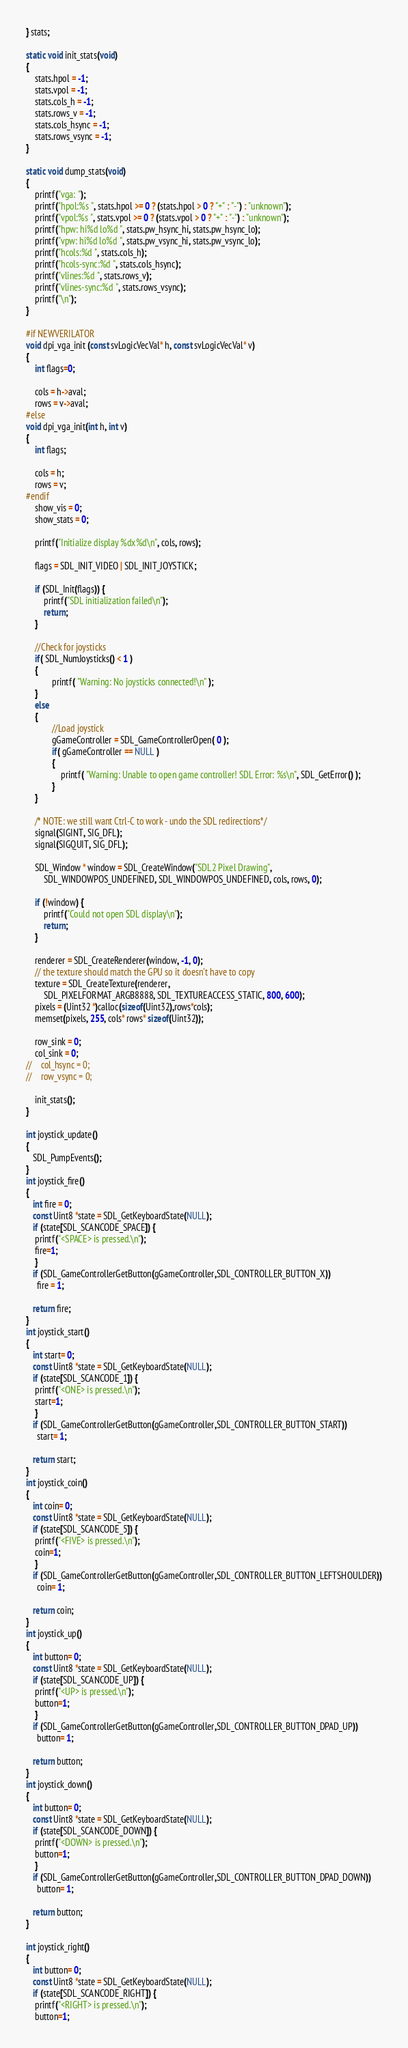<code> <loc_0><loc_0><loc_500><loc_500><_C++_>} stats;

static void init_stats(void)
{
    stats.hpol = -1;
    stats.vpol = -1;
    stats.cols_h = -1;
    stats.rows_v = -1;
    stats.cols_hsync = -1;
    stats.rows_vsync = -1;
}

static void dump_stats(void)
{
    printf("vga: ");
    printf("hpol:%s ", stats.hpol >= 0 ? (stats.hpol > 0 ? "+" : "-") : "unknown");
    printf("vpol:%s ", stats.vpol >= 0 ? (stats.vpol > 0 ? "+" : "-") : "unknown");
    printf("hpw: hi%d lo%d ", stats.pw_hsync_hi, stats.pw_hsync_lo);
    printf("vpw: hi%d lo%d ", stats.pw_vsync_hi, stats.pw_vsync_lo);
    printf("hcols:%d ", stats.cols_h);
    printf("hcols-sync:%d ", stats.cols_hsync);
    printf("vlines:%d ", stats.rows_v);
    printf("vlines-sync:%d ", stats.rows_vsync);
    printf("\n");
}

#if NEWVERILATOR
void dpi_vga_init (const svLogicVecVal* h, const svLogicVecVal* v)
{
    int flags=0;

    cols = h->aval;
    rows = v->aval;
#else
void dpi_vga_init(int h, int v)
{
    int flags;

    cols = h;
    rows = v;
#endif
    show_vis = 0;
    show_stats = 0;

    printf("Initialize display %dx%d\n", cols, rows);

    flags = SDL_INIT_VIDEO | SDL_INIT_JOYSTICK;

    if (SDL_Init(flags)) {
        printf("SDL initialization failed\n");
        return;
    }

    //Check for joysticks
    if( SDL_NumJoysticks() < 1 )
    {
            printf( "Warning: No joysticks connected!\n" );
    }
    else
    {
            //Load joystick
            gGameController = SDL_GameControllerOpen( 0 );
            if( gGameController == NULL )
            {
                printf( "Warning: Unable to open game controller! SDL Error: %s\n", SDL_GetError() );
            }
    }

    /* NOTE: we still want Ctrl-C to work - undo the SDL redirections*/
    signal(SIGINT, SIG_DFL);
    signal(SIGQUIT, SIG_DFL);

    SDL_Window * window = SDL_CreateWindow("SDL2 Pixel Drawing",
        SDL_WINDOWPOS_UNDEFINED, SDL_WINDOWPOS_UNDEFINED, cols, rows, 0);

    if (!window) {
        printf("Could not open SDL display\n");
        return;
    }

    renderer = SDL_CreateRenderer(window, -1, 0);
    // the texture should match the GPU so it doesn't have to copy
    texture = SDL_CreateTexture(renderer,
        SDL_PIXELFORMAT_ARGB8888, SDL_TEXTUREACCESS_STATIC, 800, 600);
    pixels = (Uint32 *)calloc(sizeof(Uint32),rows*cols);
    memset(pixels, 255, cols* rows* sizeof(Uint32));

    row_sink = 0;
    col_sink = 0;
//    col_hsync = 0;
//    row_vsync = 0;

    init_stats();
}

int joystick_update() 
{
   SDL_PumpEvents();
}
int joystick_fire() 
{
   int fire = 0;
   const Uint8 *state = SDL_GetKeyboardState(NULL);
   if (state[SDL_SCANCODE_SPACE]) {
    printf("<SPACE> is pressed.\n");
    fire=1;
    }
   if (SDL_GameControllerGetButton(gGameController,SDL_CONTROLLER_BUTTON_X))
     fire = 1;

   return fire;
}
int joystick_start() 
{
   int start= 0;
   const Uint8 *state = SDL_GetKeyboardState(NULL);
   if (state[SDL_SCANCODE_1]) {
    printf("<ONE> is pressed.\n");
    start=1;
    }
   if (SDL_GameControllerGetButton(gGameController,SDL_CONTROLLER_BUTTON_START))
     start= 1;

   return start;
}
int joystick_coin() 
{
   int coin= 0;
   const Uint8 *state = SDL_GetKeyboardState(NULL);
   if (state[SDL_SCANCODE_5]) {
    printf("<FIVE> is pressed.\n");
    coin=1;
    }
   if (SDL_GameControllerGetButton(gGameController,SDL_CONTROLLER_BUTTON_LEFTSHOULDER))
     coin= 1;

   return coin;
}
int joystick_up() 
{
   int button= 0;
   const Uint8 *state = SDL_GetKeyboardState(NULL);
   if (state[SDL_SCANCODE_UP]) {
    printf("<UP> is pressed.\n");
    button=1;
    }
   if (SDL_GameControllerGetButton(gGameController,SDL_CONTROLLER_BUTTON_DPAD_UP))
     button= 1;

   return button;
}
int joystick_down() 
{
   int button= 0;
   const Uint8 *state = SDL_GetKeyboardState(NULL);
   if (state[SDL_SCANCODE_DOWN]) {
    printf("<DOWN> is pressed.\n");
    button=1;
    }
   if (SDL_GameControllerGetButton(gGameController,SDL_CONTROLLER_BUTTON_DPAD_DOWN))
     button= 1;

   return button;
}

int joystick_right() 
{
   int button= 0;
   const Uint8 *state = SDL_GetKeyboardState(NULL);
   if (state[SDL_SCANCODE_RIGHT]) {
    printf("<RIGHT> is pressed.\n");
    button=1;</code> 